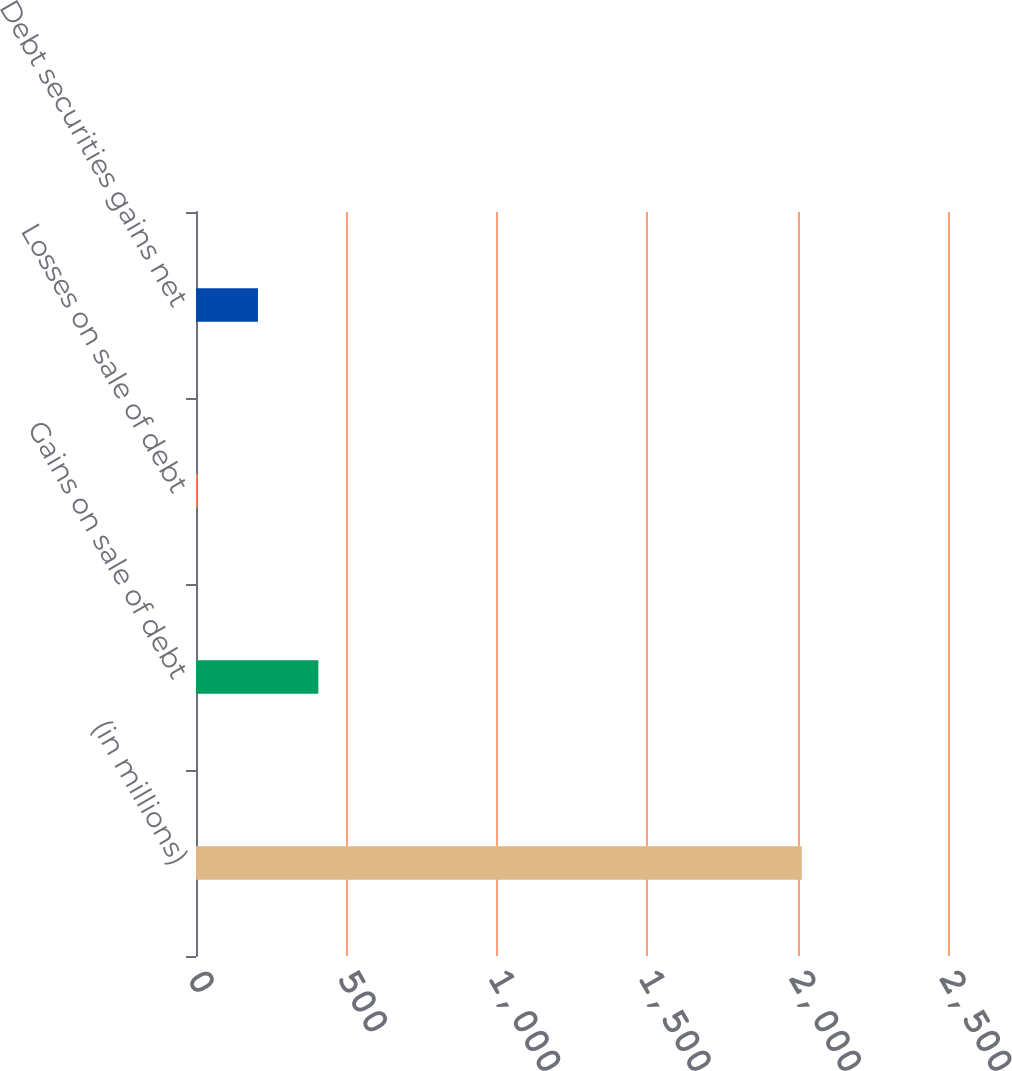Convert chart. <chart><loc_0><loc_0><loc_500><loc_500><bar_chart><fcel>(in millions)<fcel>Gains on sale of debt<fcel>Losses on sale of debt<fcel>Debt securities gains net<nl><fcel>2014<fcel>406.8<fcel>5<fcel>205.9<nl></chart> 